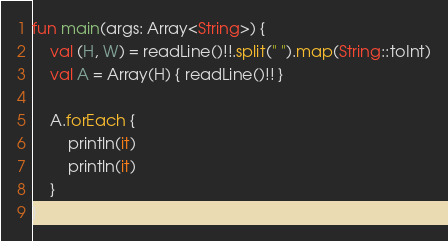<code> <loc_0><loc_0><loc_500><loc_500><_Kotlin_>fun main(args: Array<String>) {
    val (H, W) = readLine()!!.split(" ").map(String::toInt)
    val A = Array(H) { readLine()!! }

    A.forEach {
        println(it)
        println(it)
    }
}

</code> 